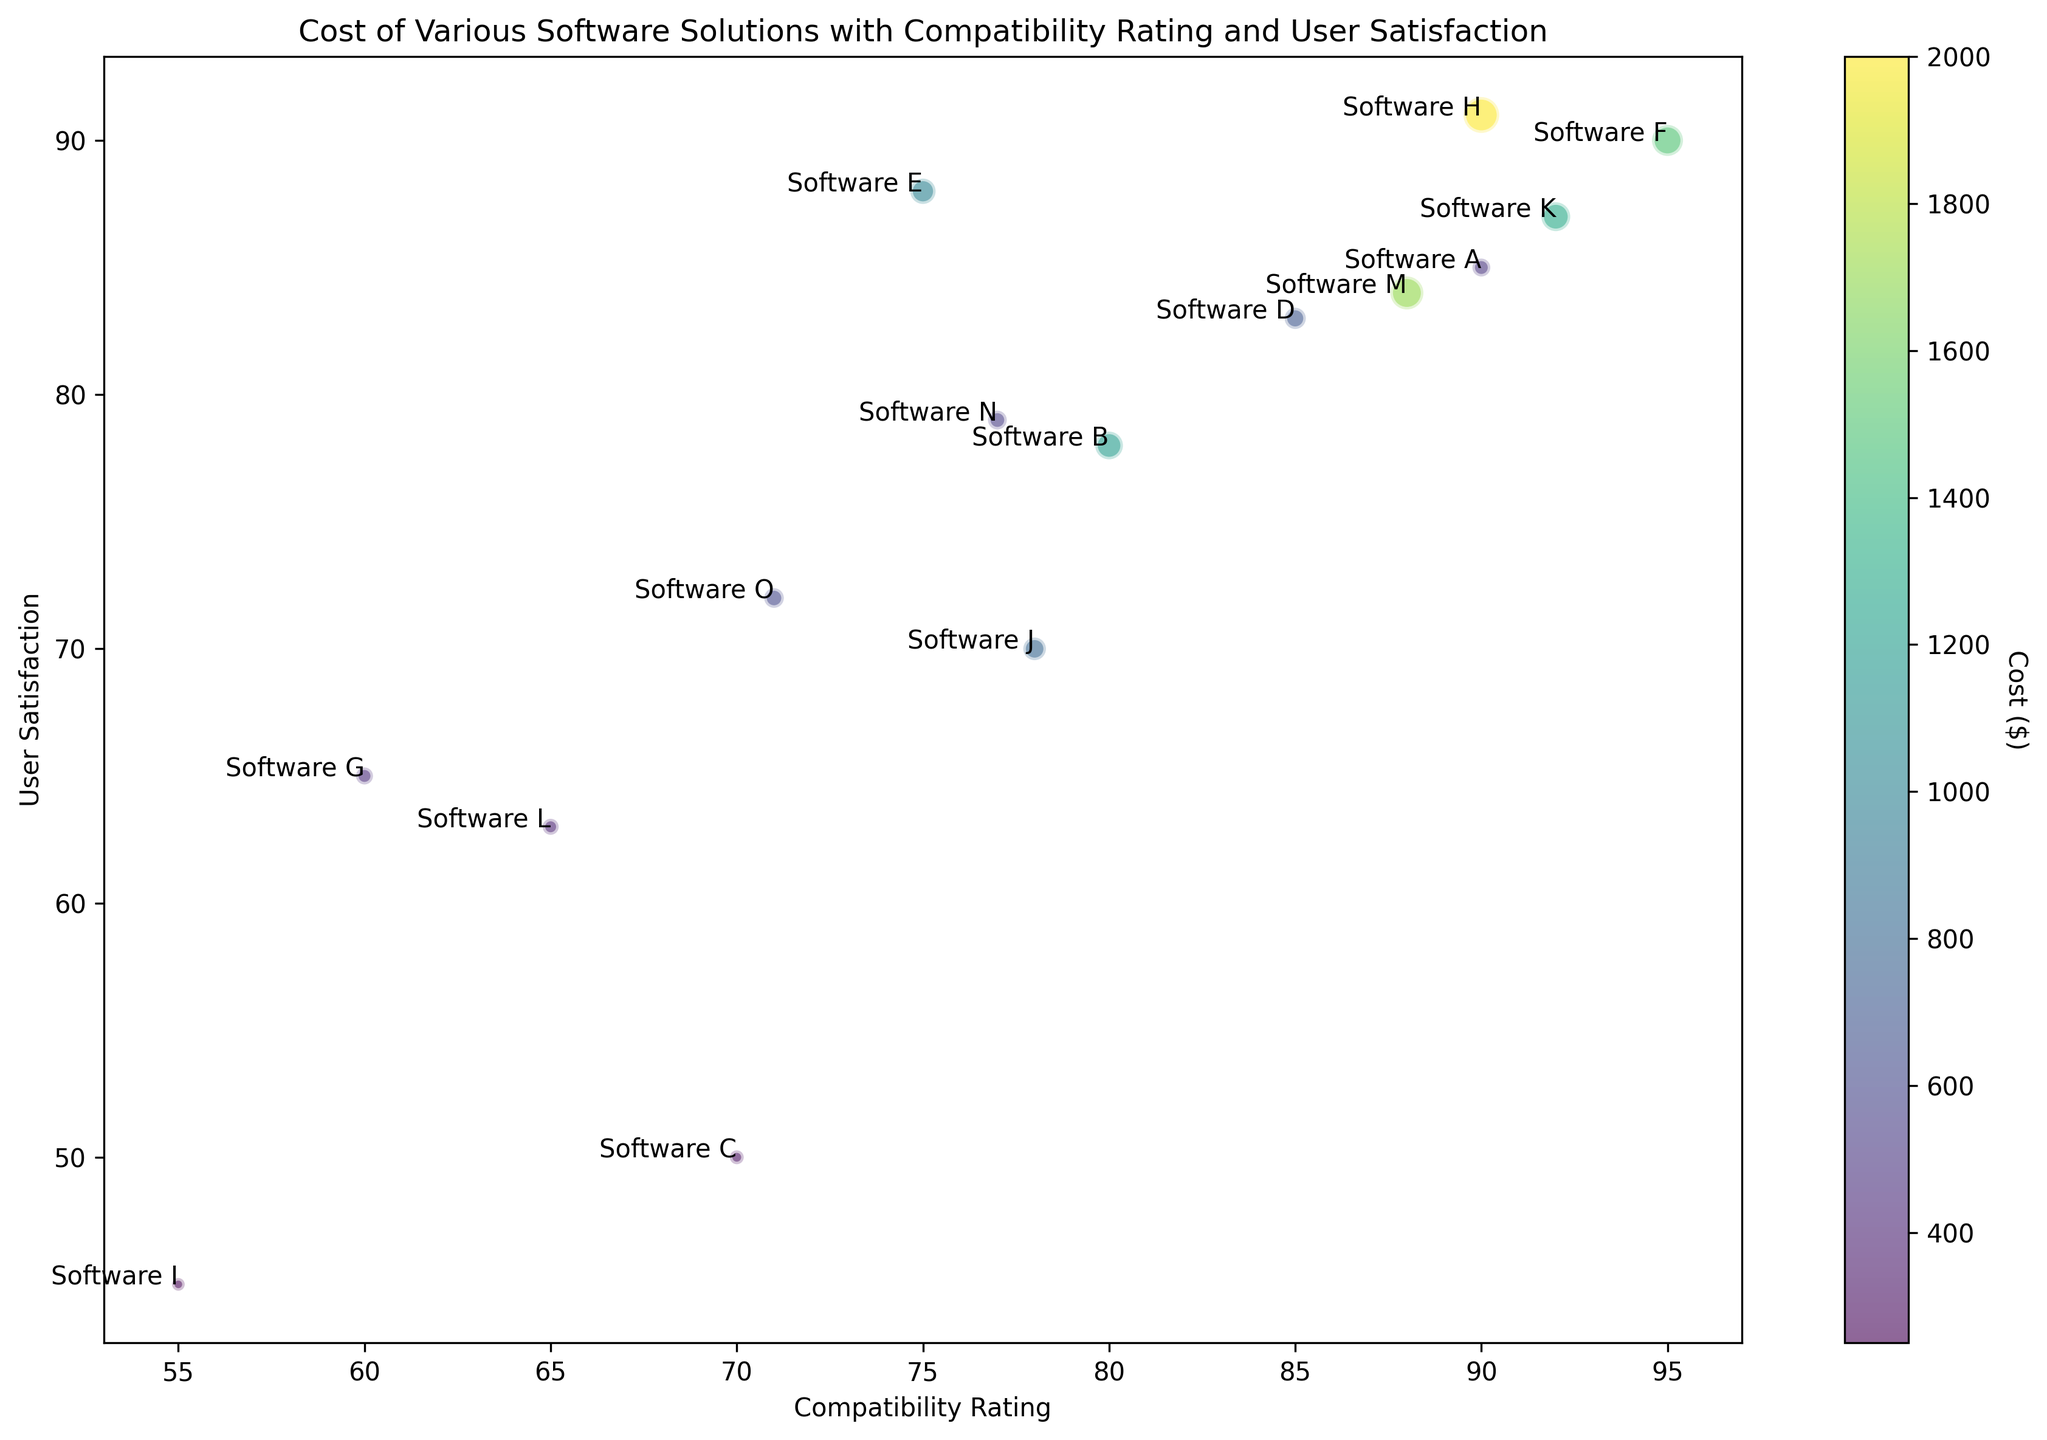What is the cost of the software with the highest compatibility rating? The software with the highest compatibility rating (95) is Software F. Referring to the bubble chart, the cost associated with Software F is $1500.
Answer: $1500 Which software has the lowest user satisfaction rating, and what is its cost? The lowest user satisfaction rating is 45, corresponding to Software I. The cost of Software I, according to the bubble chart, is $250.
Answer: $250 Which bubble represents the software with the highest user satisfaction, and what are its compatibility rating and cost? The highest user satisfaction rating is 91, corresponding to Software H. The compatibility rating and cost of Software H are 90 and $2000, respectively.
Answer: Compatibility: 90, Cost: $2000 Among Software A and Software L, which has a higher user satisfaction rating, and by how much? Comparing Software A with a user satisfaction rating of 85 and Software L with 63, Software A has a higher rating. The difference in user satisfaction is 85 - 63 = 22.
Answer: Software A, by 22 Identify the software with the smallest bubble on the chart. What are its compatibility rating and user satisfaction? The smallest bubble represents Software I because it has the lowest cost ($250). Its compatibility rating is 55 and its user satisfaction is 45.
Answer: Compatibility: 55, Satisfaction: 45 Which software has the highest cost but does not have the highest user satisfaction? Software H has the highest cost ($2000) but does not have the highest user satisfaction, which is 91. The highest user satisfaction is 91 (also Software H and Software F equally), so another answer would be Software F at $1500.
Answer: Software F What is the combined cost of Software J and Software O, and which has higher user satisfaction? The combined cost of Software J and Software O is $800 + $600 = $1400. Between them, Software O has higher user satisfaction (72 compared to Software J's 70).
Answer: Combined Cost: $1400, Higher Satisfaction: Software O Compare Software B and Software M in terms of their compatibility rating and user satisfaction. Which software performs better overall? Software B has a compatibility rating of 80 and user satisfaction of 78. Software M has a compatibility rating of 88 and user satisfaction of 84. Software M performs better overall in both categories.
Answer: Software M What is the average user satisfaction rating of all software solutions priced over $1000? The software solutions priced over $1000 are Software B (78), Software F (90), Software H (91), Software K (87), and Software M (84). The average user satisfaction is (78 + 90 + 91 + 87 + 84) / 5 = 86.
Answer: 86 